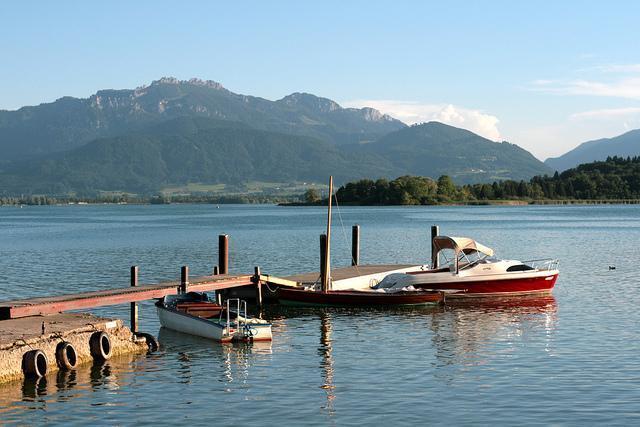How many boats are there?
Give a very brief answer. 2. How many tires are used a bumpers on the dock?
Give a very brief answer. 3. How many boats are in the photo?
Give a very brief answer. 2. How many bikes are on the car?
Give a very brief answer. 0. 